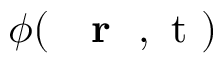<formula> <loc_0><loc_0><loc_500><loc_500>\phi ( { r } , t )</formula> 